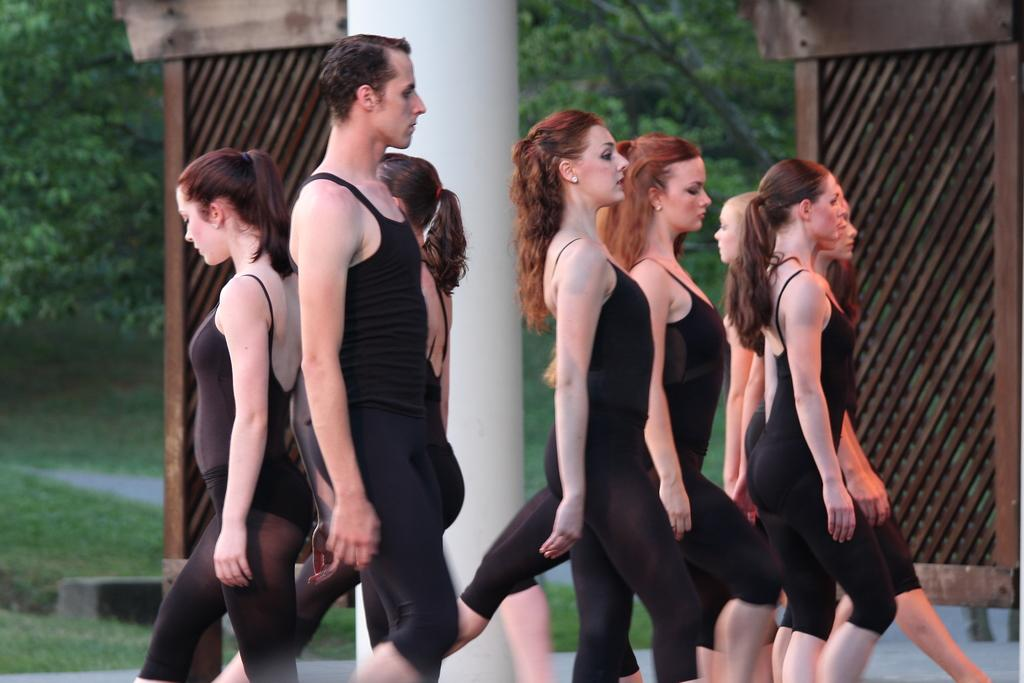What are the people in the image doing? The people in the image are walking. What type of vegetation is present in the image? There are trees in the image. What objects can be seen in the image besides the trees? There are boards and a pillar in the image. What is the ground covered with in the image? The ground is covered with grass in the image. Can you tell me how many times the zipper is used in the image? There is no zipper present in the image. What type of play is happening in the image? There is no play or specific activity being performed in the image; it simply shows people walking. 